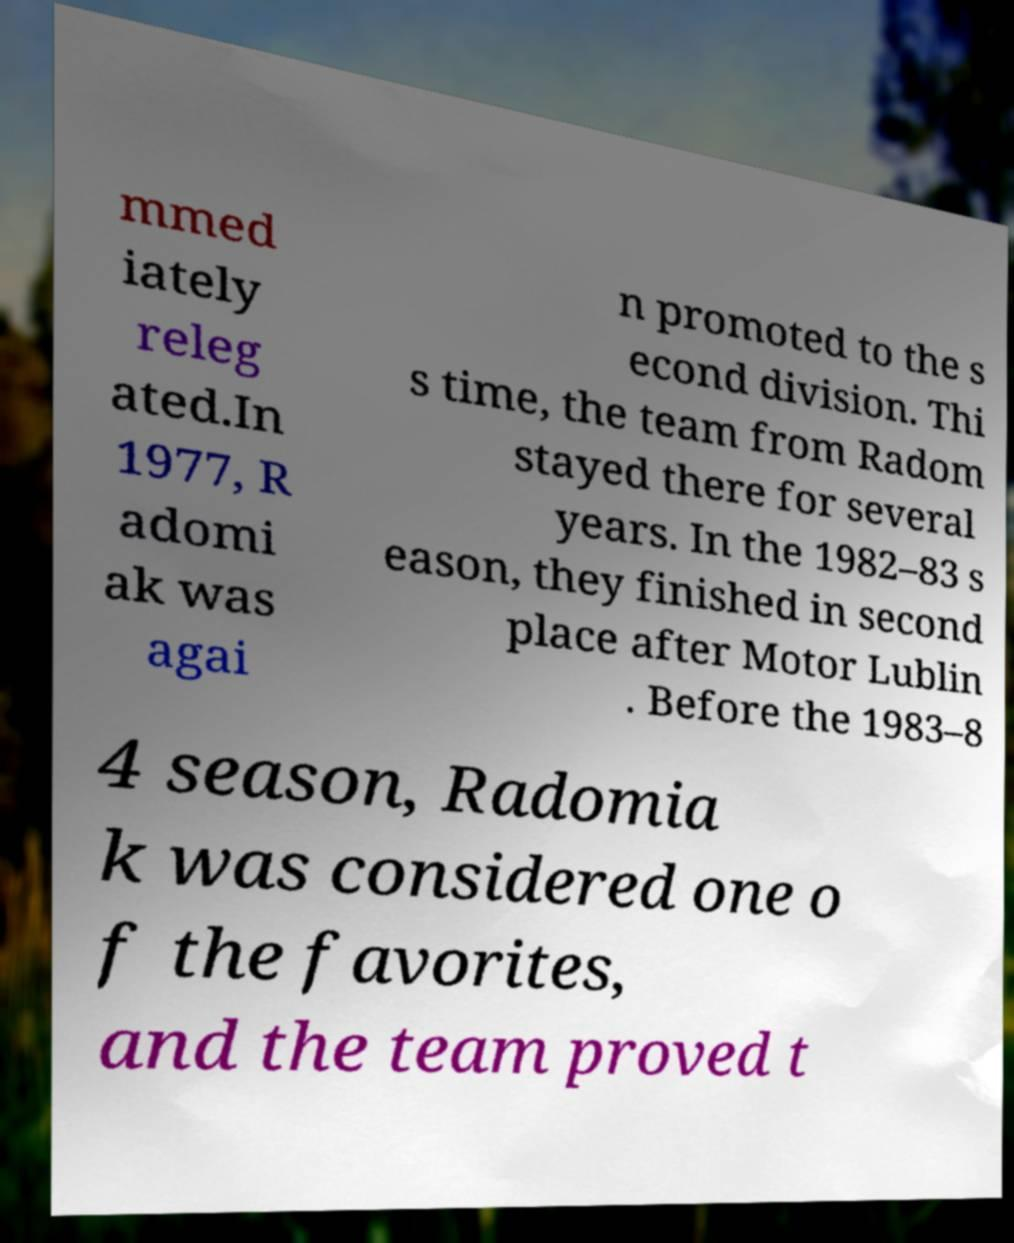Please identify and transcribe the text found in this image. mmed iately releg ated.In 1977, R adomi ak was agai n promoted to the s econd division. Thi s time, the team from Radom stayed there for several years. In the 1982–83 s eason, they finished in second place after Motor Lublin . Before the 1983–8 4 season, Radomia k was considered one o f the favorites, and the team proved t 